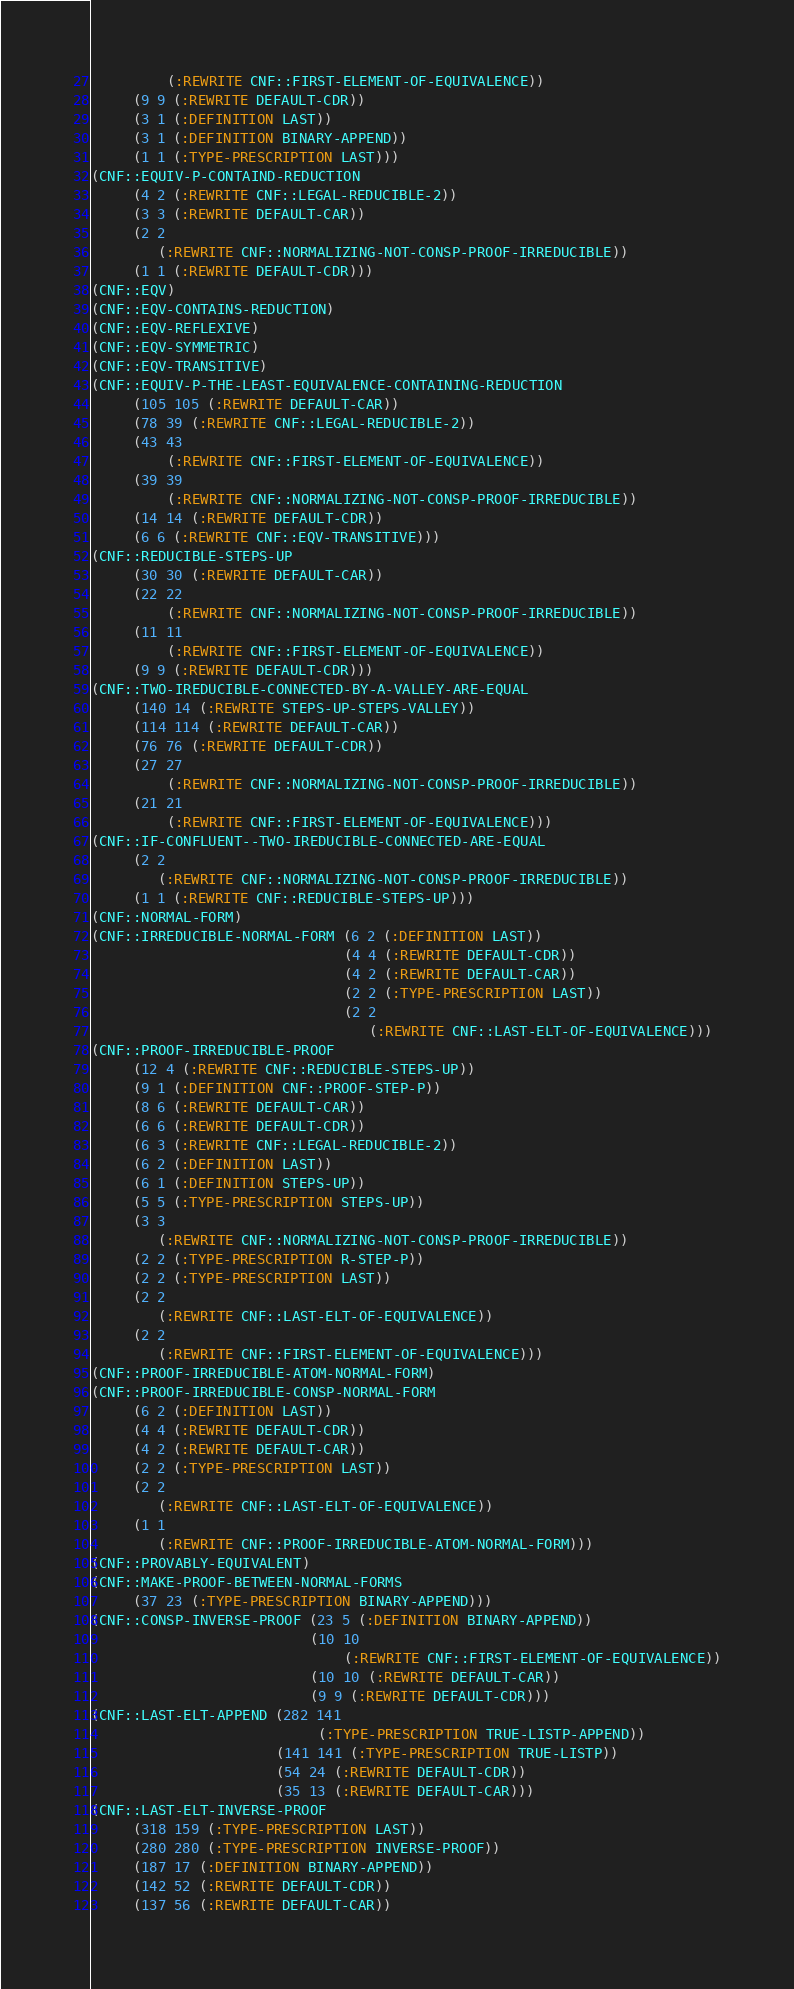Convert code to text. <code><loc_0><loc_0><loc_500><loc_500><_Lisp_>         (:REWRITE CNF::FIRST-ELEMENT-OF-EQUIVALENCE))
     (9 9 (:REWRITE DEFAULT-CDR))
     (3 1 (:DEFINITION LAST))
     (3 1 (:DEFINITION BINARY-APPEND))
     (1 1 (:TYPE-PRESCRIPTION LAST)))
(CNF::EQUIV-P-CONTAIND-REDUCTION
     (4 2 (:REWRITE CNF::LEGAL-REDUCIBLE-2))
     (3 3 (:REWRITE DEFAULT-CAR))
     (2 2
        (:REWRITE CNF::NORMALIZING-NOT-CONSP-PROOF-IRREDUCIBLE))
     (1 1 (:REWRITE DEFAULT-CDR)))
(CNF::EQV)
(CNF::EQV-CONTAINS-REDUCTION)
(CNF::EQV-REFLEXIVE)
(CNF::EQV-SYMMETRIC)
(CNF::EQV-TRANSITIVE)
(CNF::EQUIV-P-THE-LEAST-EQUIVALENCE-CONTAINING-REDUCTION
     (105 105 (:REWRITE DEFAULT-CAR))
     (78 39 (:REWRITE CNF::LEGAL-REDUCIBLE-2))
     (43 43
         (:REWRITE CNF::FIRST-ELEMENT-OF-EQUIVALENCE))
     (39 39
         (:REWRITE CNF::NORMALIZING-NOT-CONSP-PROOF-IRREDUCIBLE))
     (14 14 (:REWRITE DEFAULT-CDR))
     (6 6 (:REWRITE CNF::EQV-TRANSITIVE)))
(CNF::REDUCIBLE-STEPS-UP
     (30 30 (:REWRITE DEFAULT-CAR))
     (22 22
         (:REWRITE CNF::NORMALIZING-NOT-CONSP-PROOF-IRREDUCIBLE))
     (11 11
         (:REWRITE CNF::FIRST-ELEMENT-OF-EQUIVALENCE))
     (9 9 (:REWRITE DEFAULT-CDR)))
(CNF::TWO-IREDUCIBLE-CONNECTED-BY-A-VALLEY-ARE-EQUAL
     (140 14 (:REWRITE STEPS-UP-STEPS-VALLEY))
     (114 114 (:REWRITE DEFAULT-CAR))
     (76 76 (:REWRITE DEFAULT-CDR))
     (27 27
         (:REWRITE CNF::NORMALIZING-NOT-CONSP-PROOF-IRREDUCIBLE))
     (21 21
         (:REWRITE CNF::FIRST-ELEMENT-OF-EQUIVALENCE)))
(CNF::IF-CONFLUENT--TWO-IREDUCIBLE-CONNECTED-ARE-EQUAL
     (2 2
        (:REWRITE CNF::NORMALIZING-NOT-CONSP-PROOF-IRREDUCIBLE))
     (1 1 (:REWRITE CNF::REDUCIBLE-STEPS-UP)))
(CNF::NORMAL-FORM)
(CNF::IRREDUCIBLE-NORMAL-FORM (6 2 (:DEFINITION LAST))
                              (4 4 (:REWRITE DEFAULT-CDR))
                              (4 2 (:REWRITE DEFAULT-CAR))
                              (2 2 (:TYPE-PRESCRIPTION LAST))
                              (2 2
                                 (:REWRITE CNF::LAST-ELT-OF-EQUIVALENCE)))
(CNF::PROOF-IRREDUCIBLE-PROOF
     (12 4 (:REWRITE CNF::REDUCIBLE-STEPS-UP))
     (9 1 (:DEFINITION CNF::PROOF-STEP-P))
     (8 6 (:REWRITE DEFAULT-CAR))
     (6 6 (:REWRITE DEFAULT-CDR))
     (6 3 (:REWRITE CNF::LEGAL-REDUCIBLE-2))
     (6 2 (:DEFINITION LAST))
     (6 1 (:DEFINITION STEPS-UP))
     (5 5 (:TYPE-PRESCRIPTION STEPS-UP))
     (3 3
        (:REWRITE CNF::NORMALIZING-NOT-CONSP-PROOF-IRREDUCIBLE))
     (2 2 (:TYPE-PRESCRIPTION R-STEP-P))
     (2 2 (:TYPE-PRESCRIPTION LAST))
     (2 2
        (:REWRITE CNF::LAST-ELT-OF-EQUIVALENCE))
     (2 2
        (:REWRITE CNF::FIRST-ELEMENT-OF-EQUIVALENCE)))
(CNF::PROOF-IRREDUCIBLE-ATOM-NORMAL-FORM)
(CNF::PROOF-IRREDUCIBLE-CONSP-NORMAL-FORM
     (6 2 (:DEFINITION LAST))
     (4 4 (:REWRITE DEFAULT-CDR))
     (4 2 (:REWRITE DEFAULT-CAR))
     (2 2 (:TYPE-PRESCRIPTION LAST))
     (2 2
        (:REWRITE CNF::LAST-ELT-OF-EQUIVALENCE))
     (1 1
        (:REWRITE CNF::PROOF-IRREDUCIBLE-ATOM-NORMAL-FORM)))
(CNF::PROVABLY-EQUIVALENT)
(CNF::MAKE-PROOF-BETWEEN-NORMAL-FORMS
     (37 23 (:TYPE-PRESCRIPTION BINARY-APPEND)))
(CNF::CONSP-INVERSE-PROOF (23 5 (:DEFINITION BINARY-APPEND))
                          (10 10
                              (:REWRITE CNF::FIRST-ELEMENT-OF-EQUIVALENCE))
                          (10 10 (:REWRITE DEFAULT-CAR))
                          (9 9 (:REWRITE DEFAULT-CDR)))
(CNF::LAST-ELT-APPEND (282 141
                           (:TYPE-PRESCRIPTION TRUE-LISTP-APPEND))
                      (141 141 (:TYPE-PRESCRIPTION TRUE-LISTP))
                      (54 24 (:REWRITE DEFAULT-CDR))
                      (35 13 (:REWRITE DEFAULT-CAR)))
(CNF::LAST-ELT-INVERSE-PROOF
     (318 159 (:TYPE-PRESCRIPTION LAST))
     (280 280 (:TYPE-PRESCRIPTION INVERSE-PROOF))
     (187 17 (:DEFINITION BINARY-APPEND))
     (142 52 (:REWRITE DEFAULT-CDR))
     (137 56 (:REWRITE DEFAULT-CAR))</code> 